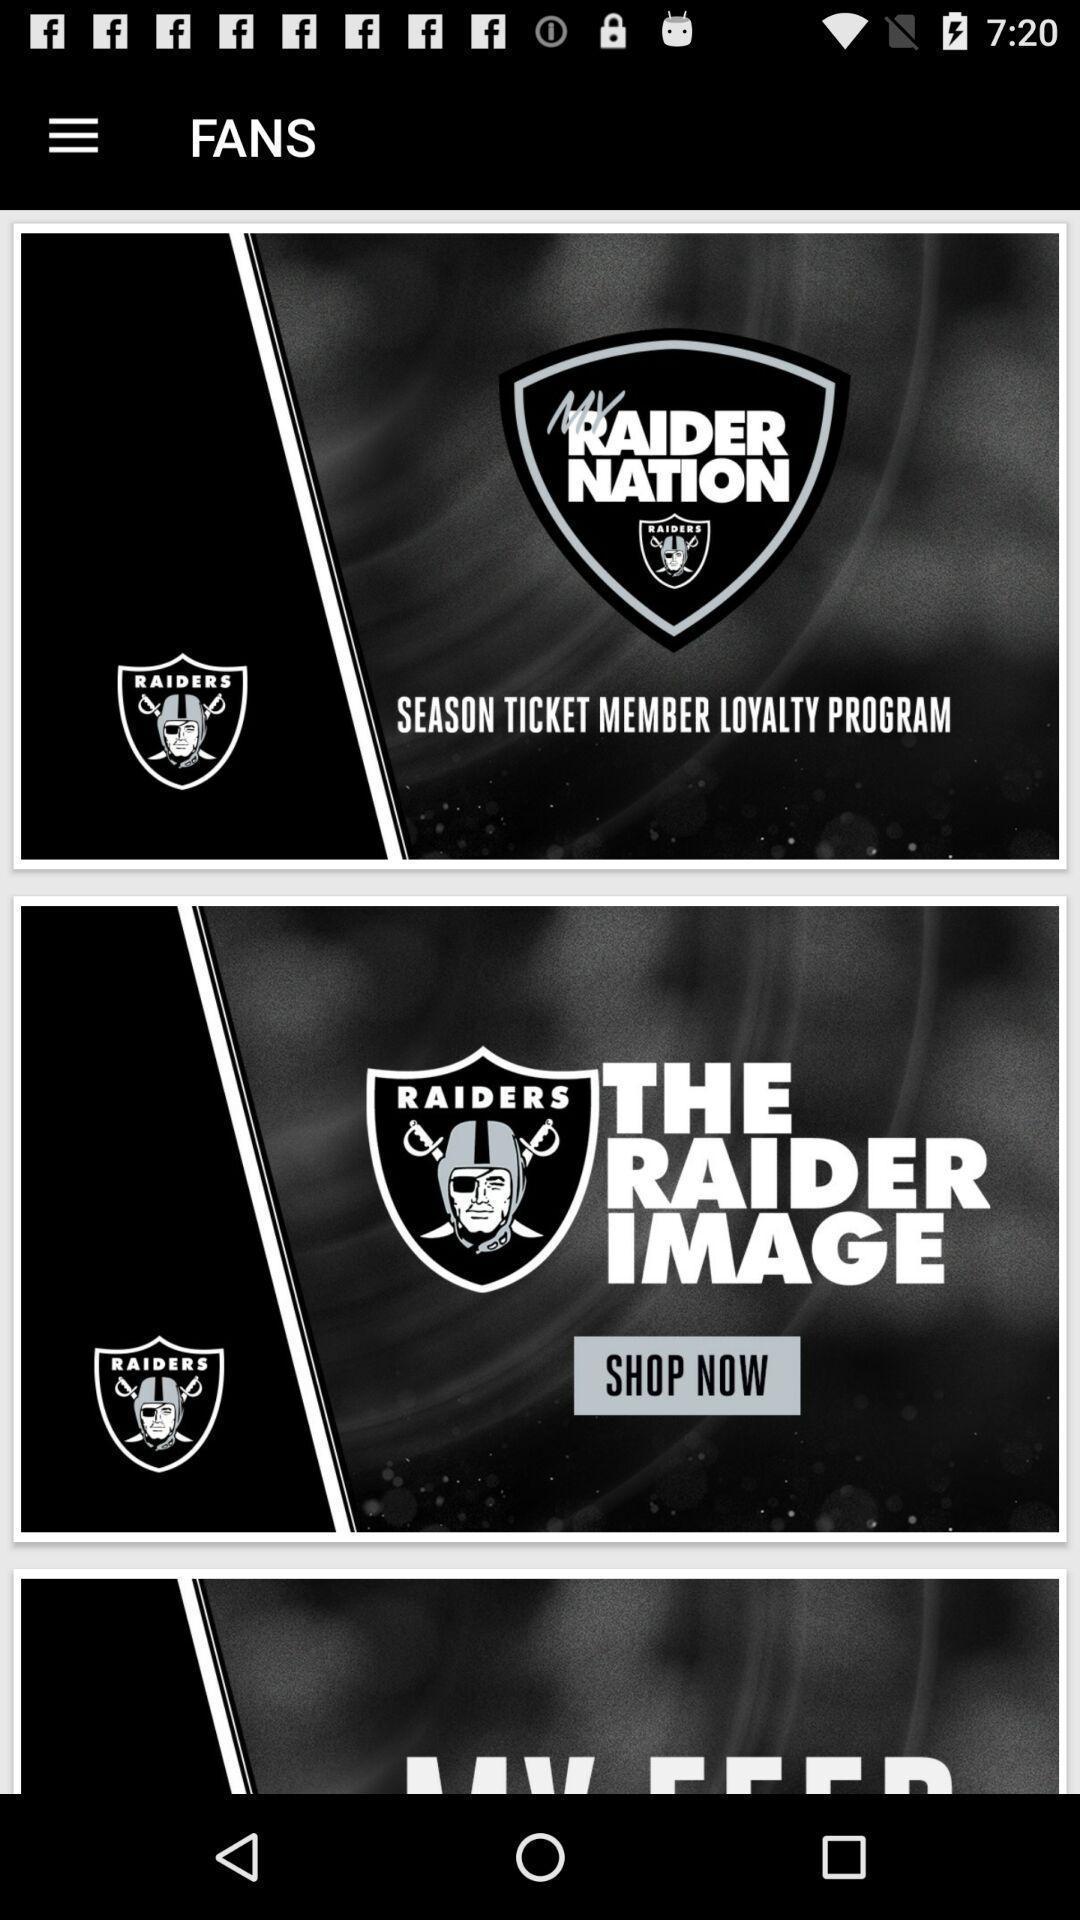What can you discern from this picture? Various types of game logos in mobile. 